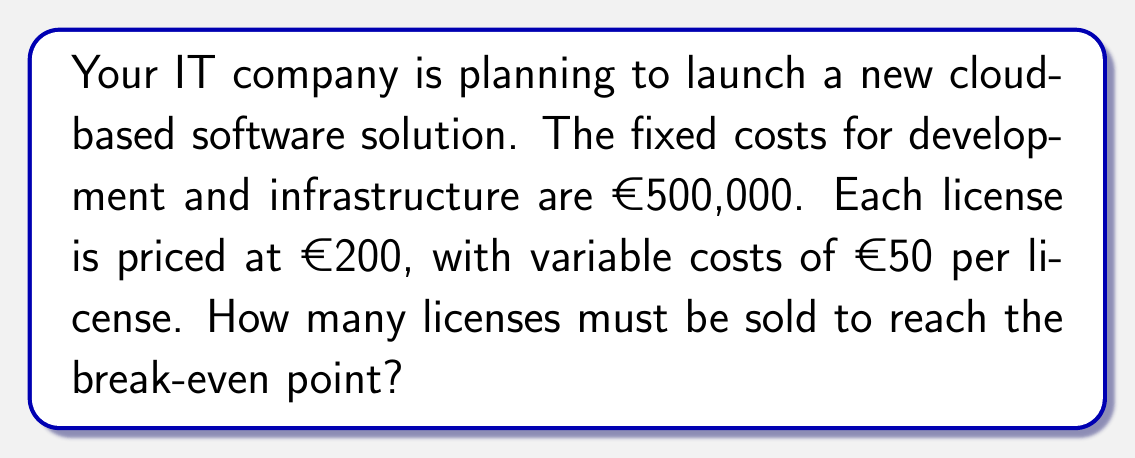What is the answer to this math problem? To calculate the break-even point, we need to determine the number of units (licenses) where total revenue equals total costs.

Let $x$ be the number of licenses sold.

1. Fixed costs (FC): €500,000
2. Price per license (P): €200
3. Variable cost per license (VC): €50

The break-even point occurs when:

Total Revenue = Total Costs

$$ TR = TC $$
$$ Px = FC + VCx $$

Substituting the values:

$$ 200x = 500,000 + 50x $$

Solving for $x$:

$$ 200x - 50x = 500,000 $$
$$ 150x = 500,000 $$
$$ x = \frac{500,000}{150} = 3,333.33 $$

Since we can't sell a fraction of a license, we round up to the nearest whole number.
Answer: 3,334 licenses 